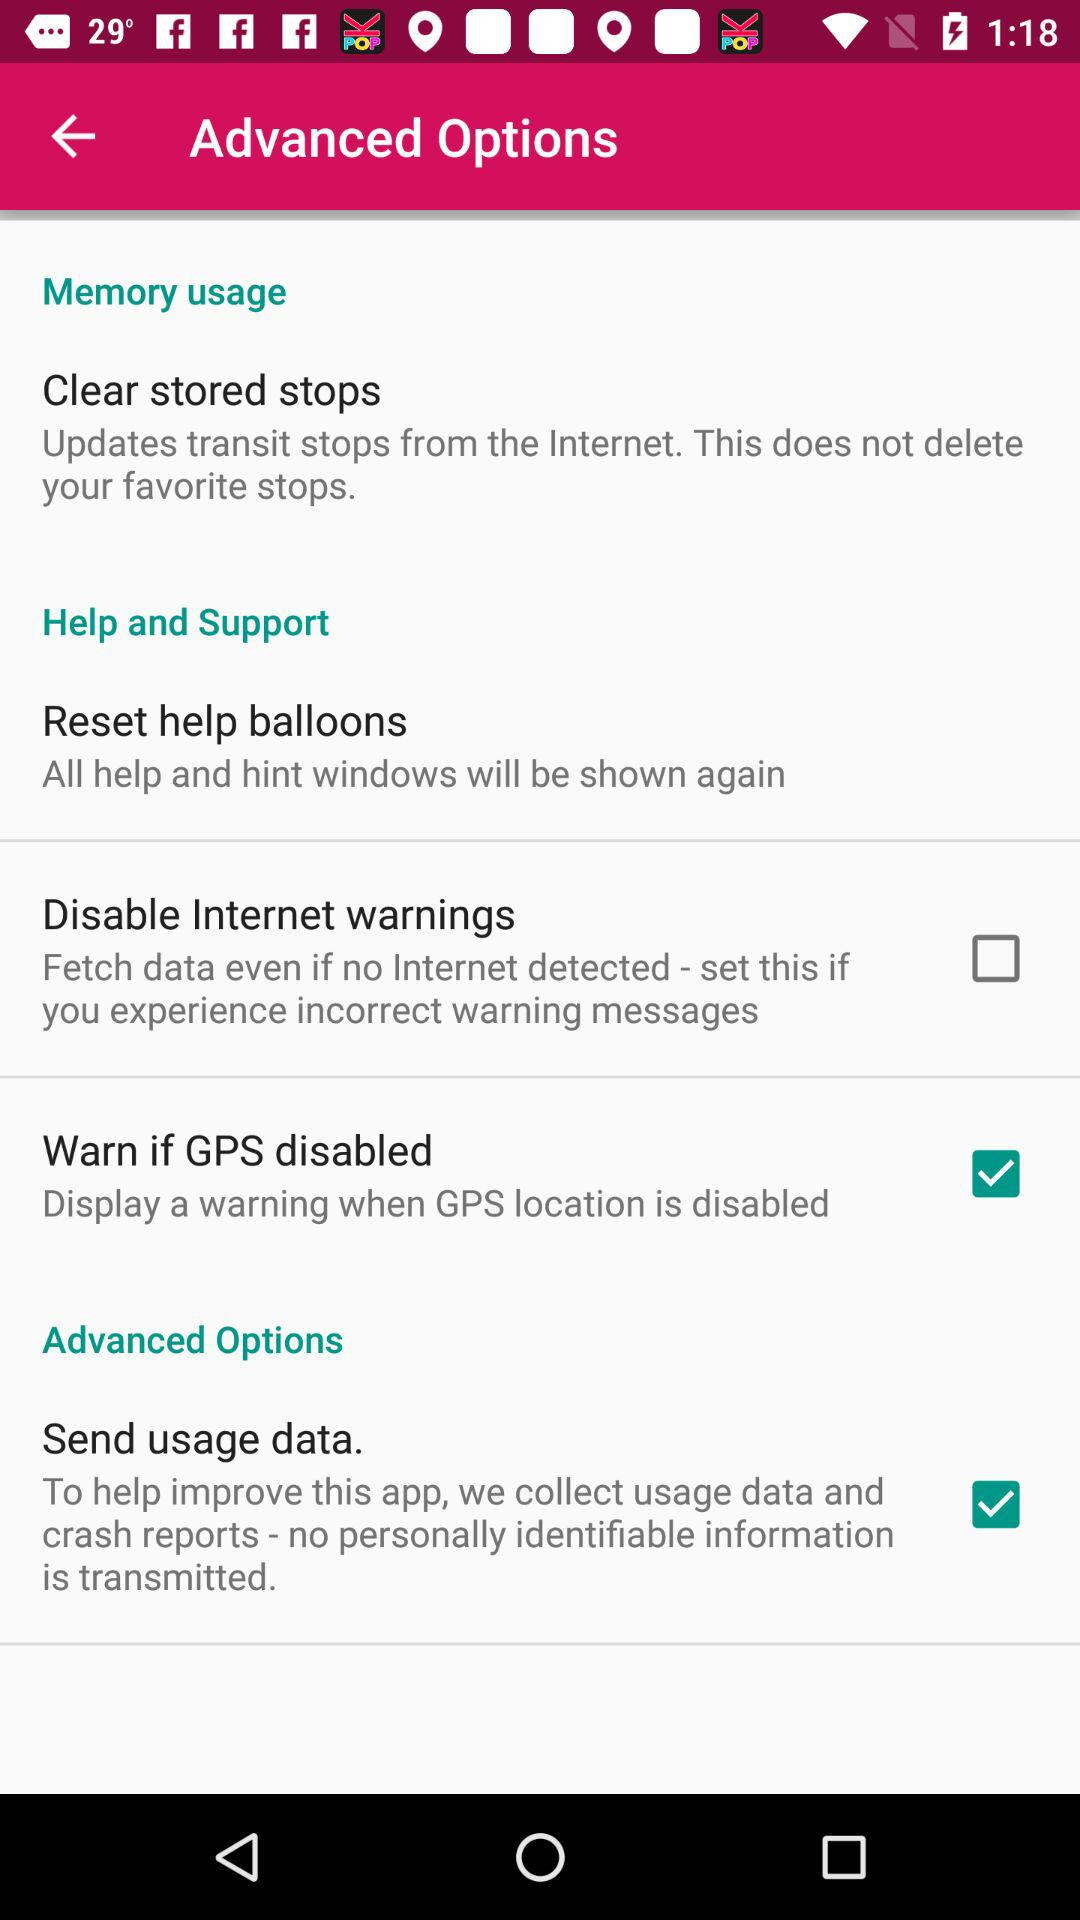What is the status of "Warn if GPS disabled"? The status is "on". 